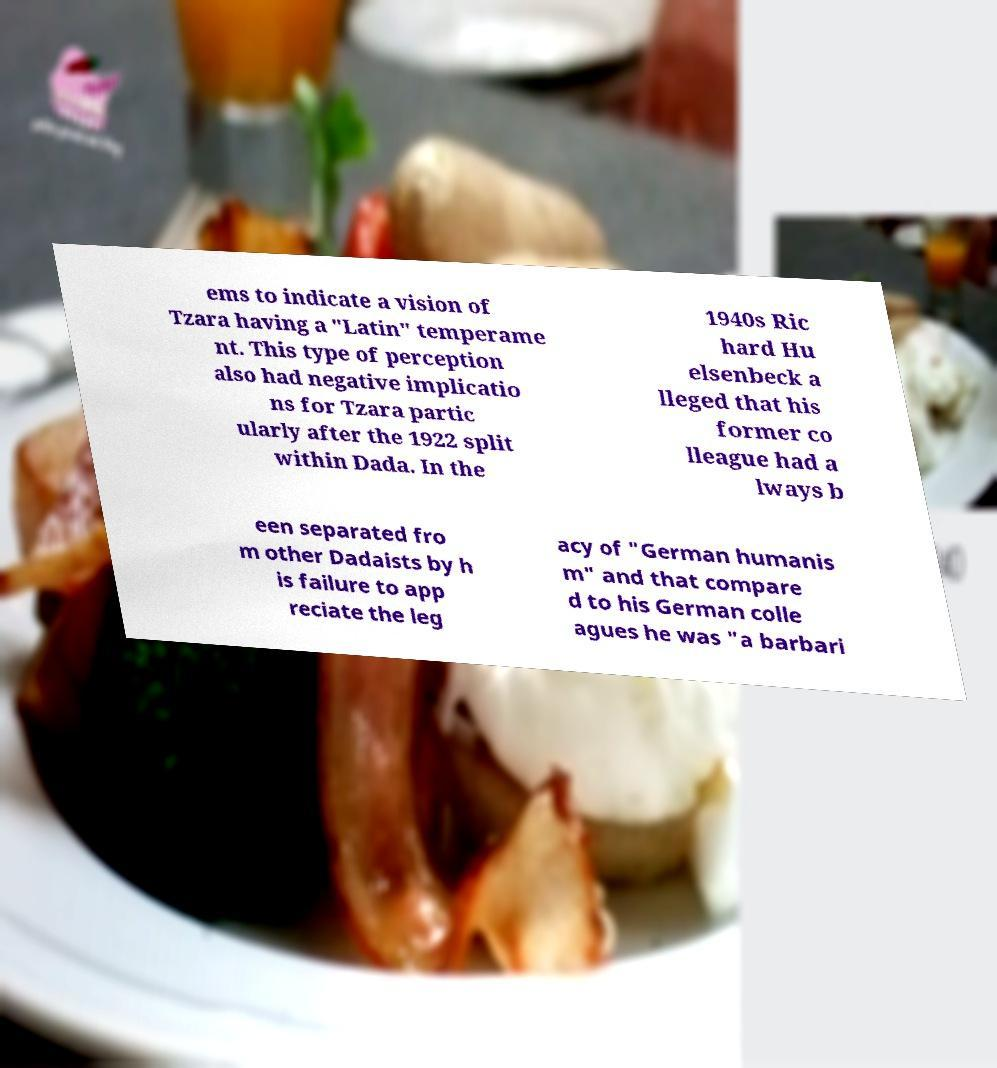Please identify and transcribe the text found in this image. ems to indicate a vision of Tzara having a "Latin" temperame nt. This type of perception also had negative implicatio ns for Tzara partic ularly after the 1922 split within Dada. In the 1940s Ric hard Hu elsenbeck a lleged that his former co lleague had a lways b een separated fro m other Dadaists by h is failure to app reciate the leg acy of "German humanis m" and that compare d to his German colle agues he was "a barbari 